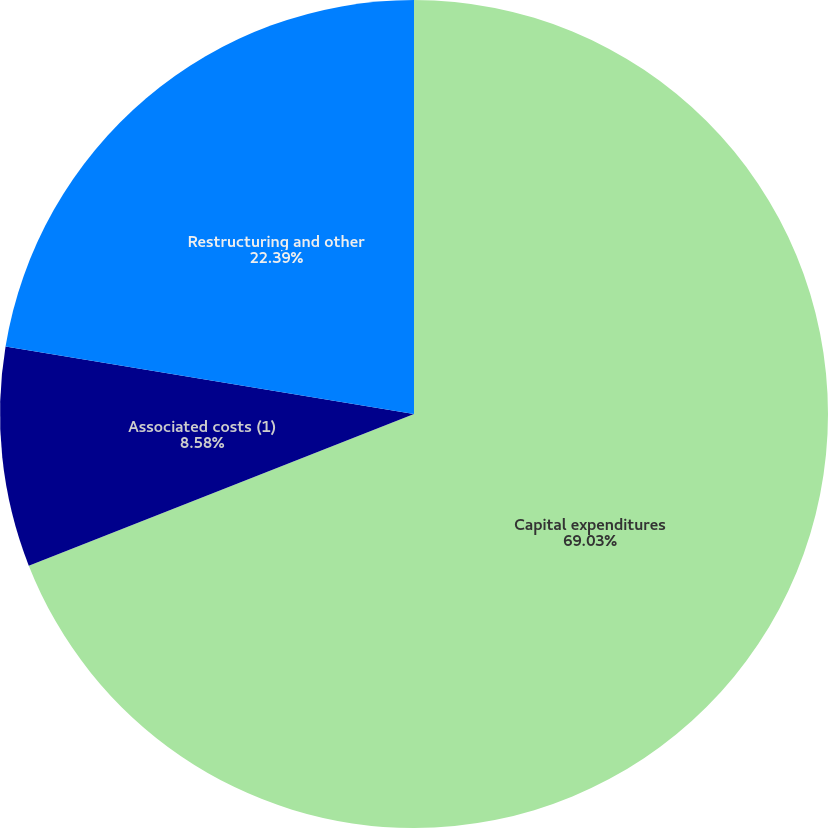Convert chart. <chart><loc_0><loc_0><loc_500><loc_500><pie_chart><fcel>Capital expenditures<fcel>Associated costs (1)<fcel>Restructuring and other<nl><fcel>69.03%<fcel>8.58%<fcel>22.39%<nl></chart> 